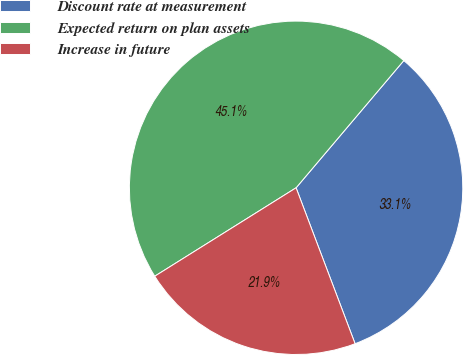Convert chart to OTSL. <chart><loc_0><loc_0><loc_500><loc_500><pie_chart><fcel>Discount rate at measurement<fcel>Expected return on plan assets<fcel>Increase in future<nl><fcel>33.06%<fcel>45.08%<fcel>21.86%<nl></chart> 